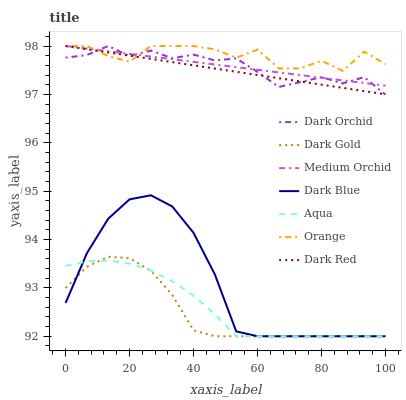Does Dark Gold have the minimum area under the curve?
Answer yes or no. Yes. Does Orange have the maximum area under the curve?
Answer yes or no. Yes. Does Dark Red have the minimum area under the curve?
Answer yes or no. No. Does Dark Red have the maximum area under the curve?
Answer yes or no. No. Is Dark Red the smoothest?
Answer yes or no. Yes. Is Orange the roughest?
Answer yes or no. Yes. Is Medium Orchid the smoothest?
Answer yes or no. No. Is Medium Orchid the roughest?
Answer yes or no. No. Does Dark Red have the lowest value?
Answer yes or no. No. Does Orange have the highest value?
Answer yes or no. Yes. Does Aqua have the highest value?
Answer yes or no. No. Is Aqua less than Orange?
Answer yes or no. Yes. Is Dark Red greater than Aqua?
Answer yes or no. Yes. Does Orange intersect Medium Orchid?
Answer yes or no. Yes. Is Orange less than Medium Orchid?
Answer yes or no. No. Is Orange greater than Medium Orchid?
Answer yes or no. No. Does Aqua intersect Orange?
Answer yes or no. No. 